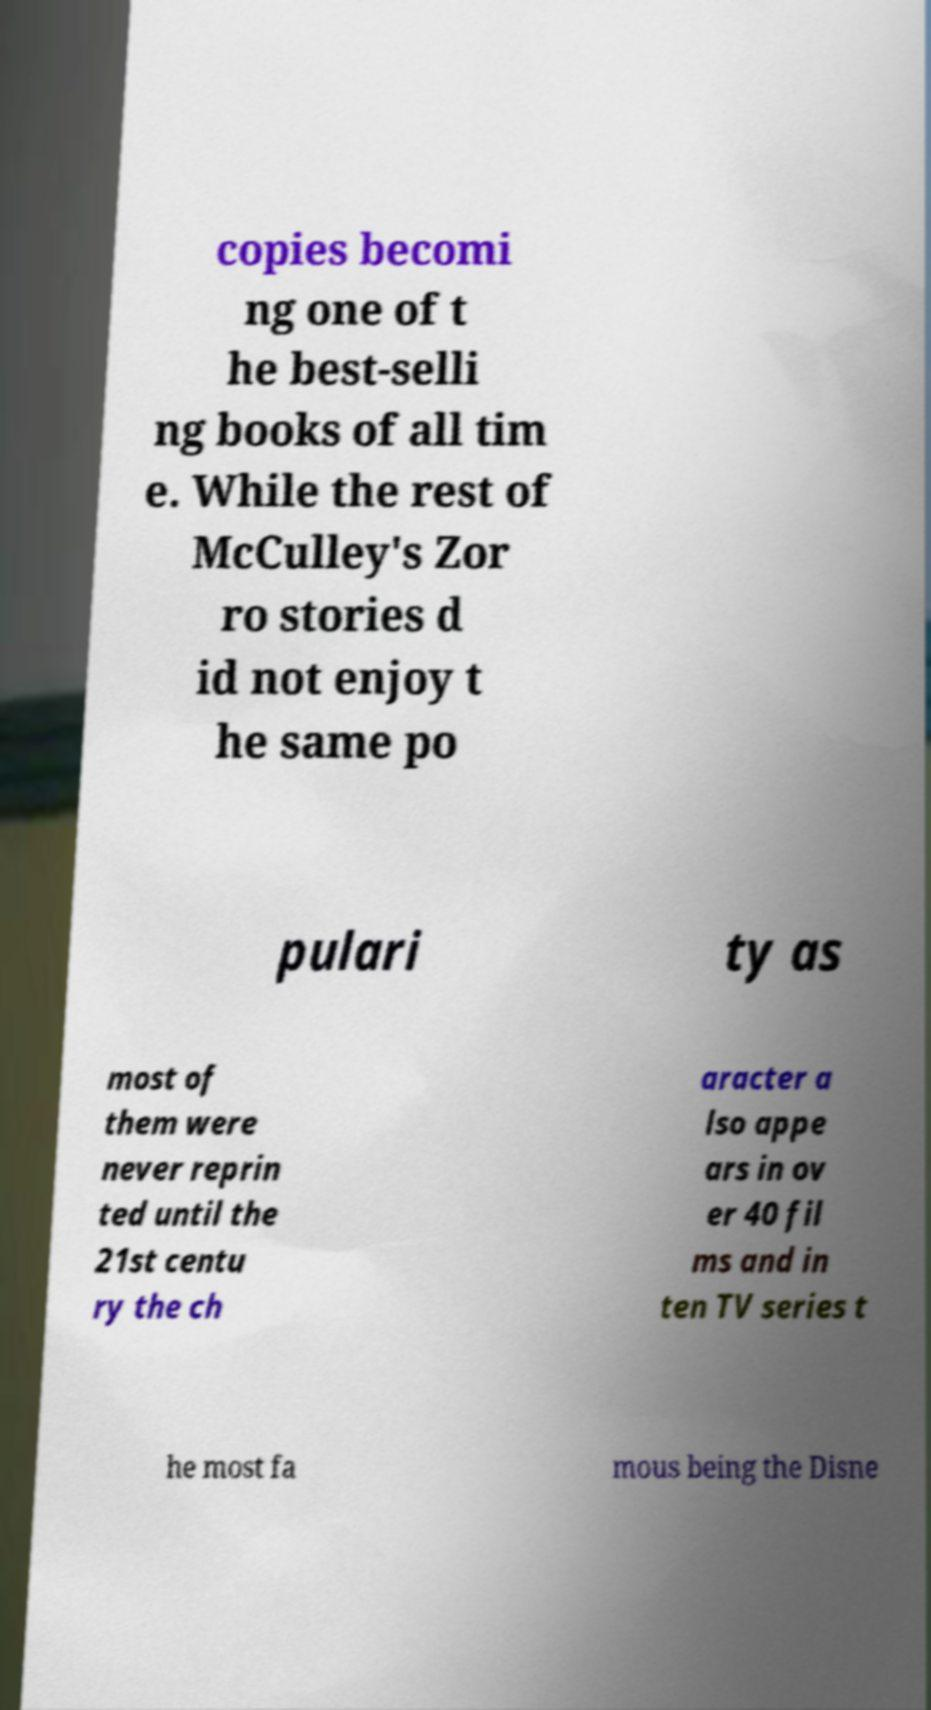For documentation purposes, I need the text within this image transcribed. Could you provide that? copies becomi ng one of t he best-selli ng books of all tim e. While the rest of McCulley's Zor ro stories d id not enjoy t he same po pulari ty as most of them were never reprin ted until the 21st centu ry the ch aracter a lso appe ars in ov er 40 fil ms and in ten TV series t he most fa mous being the Disne 